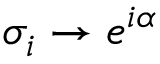<formula> <loc_0><loc_0><loc_500><loc_500>\sigma _ { i } \rightarrow e ^ { i \alpha }</formula> 